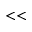Convert formula to latex. <formula><loc_0><loc_0><loc_500><loc_500>< <</formula> 